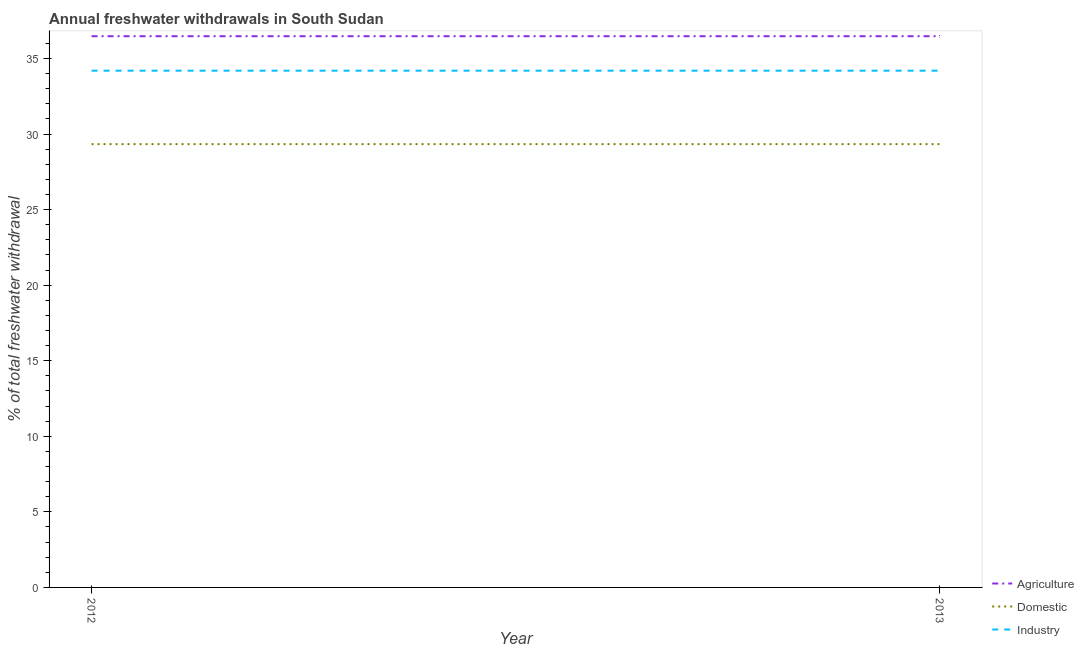How many different coloured lines are there?
Ensure brevity in your answer.  3. Does the line corresponding to percentage of freshwater withdrawal for industry intersect with the line corresponding to percentage of freshwater withdrawal for agriculture?
Provide a short and direct response. No. What is the percentage of freshwater withdrawal for agriculture in 2013?
Your answer should be compact. 36.47. Across all years, what is the maximum percentage of freshwater withdrawal for industry?
Your answer should be very brief. 34.19. Across all years, what is the minimum percentage of freshwater withdrawal for domestic purposes?
Your answer should be very brief. 29.33. In which year was the percentage of freshwater withdrawal for agriculture maximum?
Provide a short and direct response. 2012. In which year was the percentage of freshwater withdrawal for industry minimum?
Offer a very short reply. 2012. What is the total percentage of freshwater withdrawal for domestic purposes in the graph?
Give a very brief answer. 58.66. What is the difference between the percentage of freshwater withdrawal for industry in 2012 and that in 2013?
Your answer should be compact. 0. What is the difference between the percentage of freshwater withdrawal for industry in 2013 and the percentage of freshwater withdrawal for agriculture in 2012?
Keep it short and to the point. -2.28. What is the average percentage of freshwater withdrawal for agriculture per year?
Your answer should be compact. 36.47. In the year 2012, what is the difference between the percentage of freshwater withdrawal for industry and percentage of freshwater withdrawal for domestic purposes?
Provide a short and direct response. 4.86. What is the ratio of the percentage of freshwater withdrawal for agriculture in 2012 to that in 2013?
Make the answer very short. 1. In how many years, is the percentage of freshwater withdrawal for industry greater than the average percentage of freshwater withdrawal for industry taken over all years?
Offer a terse response. 0. Is it the case that in every year, the sum of the percentage of freshwater withdrawal for agriculture and percentage of freshwater withdrawal for domestic purposes is greater than the percentage of freshwater withdrawal for industry?
Offer a very short reply. Yes. Is the percentage of freshwater withdrawal for domestic purposes strictly less than the percentage of freshwater withdrawal for agriculture over the years?
Provide a short and direct response. Yes. How many lines are there?
Offer a very short reply. 3. How many years are there in the graph?
Give a very brief answer. 2. What is the difference between two consecutive major ticks on the Y-axis?
Offer a terse response. 5. Does the graph contain any zero values?
Keep it short and to the point. No. Where does the legend appear in the graph?
Ensure brevity in your answer.  Bottom right. How many legend labels are there?
Provide a succinct answer. 3. What is the title of the graph?
Offer a very short reply. Annual freshwater withdrawals in South Sudan. What is the label or title of the Y-axis?
Offer a terse response. % of total freshwater withdrawal. What is the % of total freshwater withdrawal in Agriculture in 2012?
Offer a very short reply. 36.47. What is the % of total freshwater withdrawal in Domestic in 2012?
Keep it short and to the point. 29.33. What is the % of total freshwater withdrawal in Industry in 2012?
Offer a terse response. 34.19. What is the % of total freshwater withdrawal of Agriculture in 2013?
Your response must be concise. 36.47. What is the % of total freshwater withdrawal in Domestic in 2013?
Keep it short and to the point. 29.33. What is the % of total freshwater withdrawal of Industry in 2013?
Your answer should be very brief. 34.19. Across all years, what is the maximum % of total freshwater withdrawal in Agriculture?
Provide a short and direct response. 36.47. Across all years, what is the maximum % of total freshwater withdrawal in Domestic?
Make the answer very short. 29.33. Across all years, what is the maximum % of total freshwater withdrawal of Industry?
Your answer should be compact. 34.19. Across all years, what is the minimum % of total freshwater withdrawal in Agriculture?
Keep it short and to the point. 36.47. Across all years, what is the minimum % of total freshwater withdrawal of Domestic?
Make the answer very short. 29.33. Across all years, what is the minimum % of total freshwater withdrawal in Industry?
Your answer should be very brief. 34.19. What is the total % of total freshwater withdrawal in Agriculture in the graph?
Keep it short and to the point. 72.94. What is the total % of total freshwater withdrawal in Domestic in the graph?
Your answer should be very brief. 58.66. What is the total % of total freshwater withdrawal in Industry in the graph?
Provide a short and direct response. 68.38. What is the difference between the % of total freshwater withdrawal of Agriculture in 2012 and that in 2013?
Your answer should be compact. 0. What is the difference between the % of total freshwater withdrawal of Domestic in 2012 and that in 2013?
Offer a terse response. 0. What is the difference between the % of total freshwater withdrawal in Industry in 2012 and that in 2013?
Keep it short and to the point. 0. What is the difference between the % of total freshwater withdrawal of Agriculture in 2012 and the % of total freshwater withdrawal of Domestic in 2013?
Offer a terse response. 7.14. What is the difference between the % of total freshwater withdrawal of Agriculture in 2012 and the % of total freshwater withdrawal of Industry in 2013?
Keep it short and to the point. 2.28. What is the difference between the % of total freshwater withdrawal in Domestic in 2012 and the % of total freshwater withdrawal in Industry in 2013?
Give a very brief answer. -4.86. What is the average % of total freshwater withdrawal of Agriculture per year?
Keep it short and to the point. 36.47. What is the average % of total freshwater withdrawal in Domestic per year?
Give a very brief answer. 29.33. What is the average % of total freshwater withdrawal in Industry per year?
Ensure brevity in your answer.  34.19. In the year 2012, what is the difference between the % of total freshwater withdrawal of Agriculture and % of total freshwater withdrawal of Domestic?
Provide a succinct answer. 7.14. In the year 2012, what is the difference between the % of total freshwater withdrawal in Agriculture and % of total freshwater withdrawal in Industry?
Ensure brevity in your answer.  2.28. In the year 2012, what is the difference between the % of total freshwater withdrawal in Domestic and % of total freshwater withdrawal in Industry?
Ensure brevity in your answer.  -4.86. In the year 2013, what is the difference between the % of total freshwater withdrawal in Agriculture and % of total freshwater withdrawal in Domestic?
Your response must be concise. 7.14. In the year 2013, what is the difference between the % of total freshwater withdrawal in Agriculture and % of total freshwater withdrawal in Industry?
Ensure brevity in your answer.  2.28. In the year 2013, what is the difference between the % of total freshwater withdrawal of Domestic and % of total freshwater withdrawal of Industry?
Keep it short and to the point. -4.86. What is the ratio of the % of total freshwater withdrawal in Agriculture in 2012 to that in 2013?
Your answer should be compact. 1. What is the ratio of the % of total freshwater withdrawal in Domestic in 2012 to that in 2013?
Offer a terse response. 1. What is the ratio of the % of total freshwater withdrawal of Industry in 2012 to that in 2013?
Give a very brief answer. 1. What is the difference between the highest and the lowest % of total freshwater withdrawal in Agriculture?
Make the answer very short. 0. What is the difference between the highest and the lowest % of total freshwater withdrawal in Domestic?
Give a very brief answer. 0. 